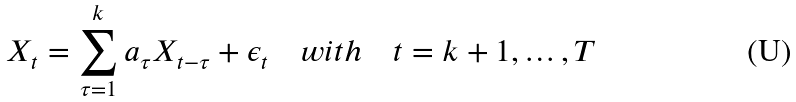Convert formula to latex. <formula><loc_0><loc_0><loc_500><loc_500>X _ { t } = \sum _ { \tau = 1 } ^ { k } a _ { \tau } X _ { t - \tau } + \epsilon _ { t } \quad w i t h \quad t = k + 1 , \dots , T</formula> 